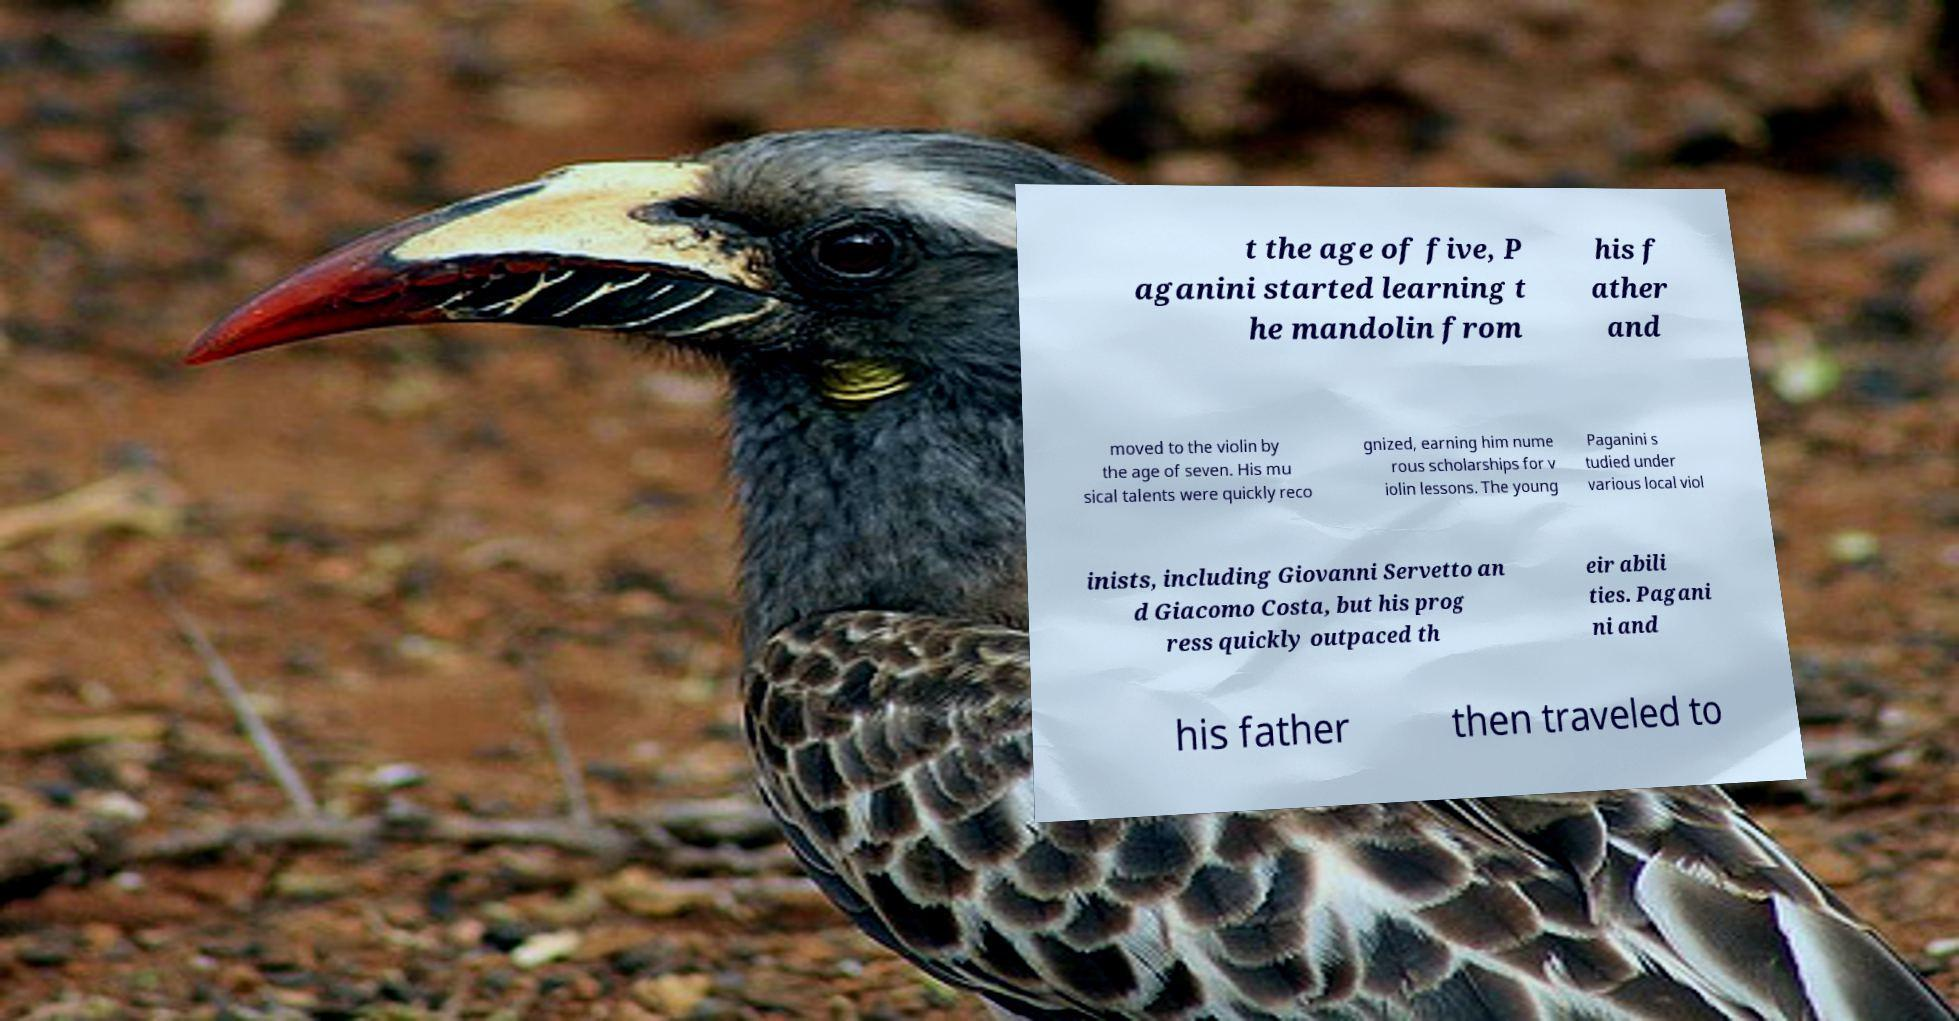For documentation purposes, I need the text within this image transcribed. Could you provide that? t the age of five, P aganini started learning t he mandolin from his f ather and moved to the violin by the age of seven. His mu sical talents were quickly reco gnized, earning him nume rous scholarships for v iolin lessons. The young Paganini s tudied under various local viol inists, including Giovanni Servetto an d Giacomo Costa, but his prog ress quickly outpaced th eir abili ties. Pagani ni and his father then traveled to 